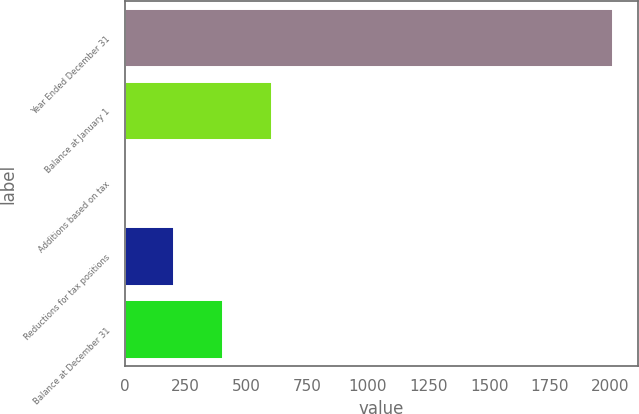Convert chart to OTSL. <chart><loc_0><loc_0><loc_500><loc_500><bar_chart><fcel>Year Ended December 31<fcel>Balance at January 1<fcel>Additions based on tax<fcel>Reductions for tax positions<fcel>Balance at December 31<nl><fcel>2011<fcel>604<fcel>1<fcel>202<fcel>403<nl></chart> 